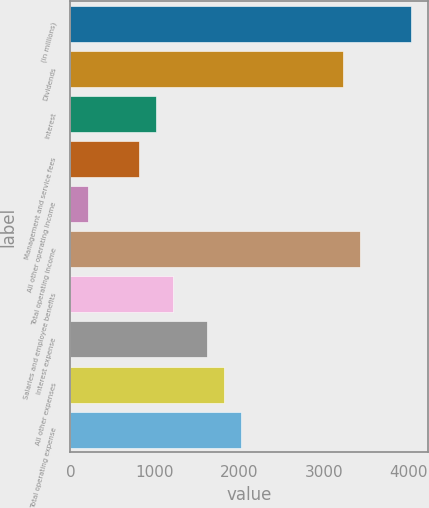Convert chart. <chart><loc_0><loc_0><loc_500><loc_500><bar_chart><fcel>(in millions)<fcel>Dividends<fcel>Interest<fcel>Management and service fees<fcel>All other operating income<fcel>Total operating income<fcel>Salaries and employee benefits<fcel>Interest expense<fcel>All other expenses<fcel>Total operating expense<nl><fcel>4026<fcel>3221.2<fcel>1008<fcel>806.8<fcel>203.2<fcel>3422.4<fcel>1209.2<fcel>1611.6<fcel>1812.8<fcel>2014<nl></chart> 